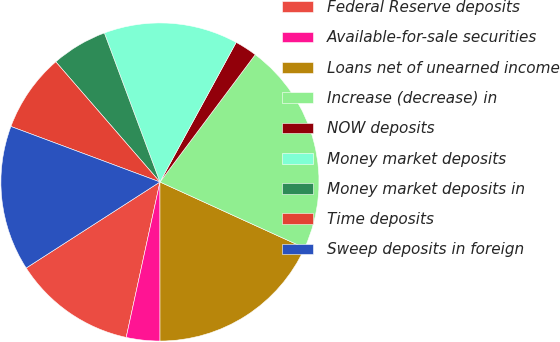<chart> <loc_0><loc_0><loc_500><loc_500><pie_chart><fcel>Federal Reserve deposits<fcel>Available-for-sale securities<fcel>Loans net of unearned income<fcel>Increase (decrease) in<fcel>NOW deposits<fcel>Money market deposits<fcel>Money market deposits in<fcel>Time deposits<fcel>Sweep deposits in foreign<nl><fcel>12.5%<fcel>3.41%<fcel>18.18%<fcel>21.59%<fcel>2.27%<fcel>13.64%<fcel>5.68%<fcel>7.96%<fcel>14.77%<nl></chart> 